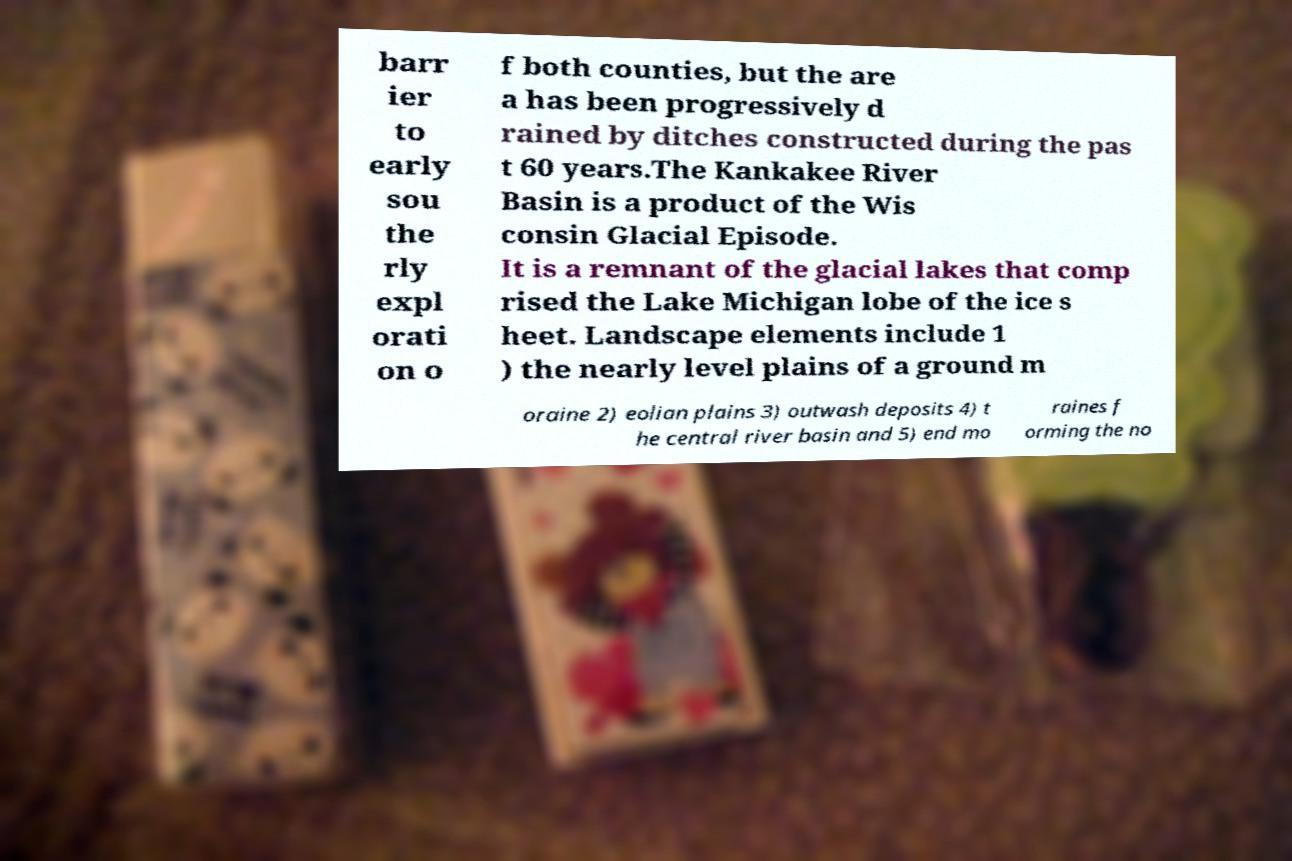What messages or text are displayed in this image? I need them in a readable, typed format. barr ier to early sou the rly expl orati on o f both counties, but the are a has been progressively d rained by ditches constructed during the pas t 60 years.The Kankakee River Basin is a product of the Wis consin Glacial Episode. It is a remnant of the glacial lakes that comp rised the Lake Michigan lobe of the ice s heet. Landscape elements include 1 ) the nearly level plains of a ground m oraine 2) eolian plains 3) outwash deposits 4) t he central river basin and 5) end mo raines f orming the no 